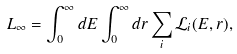<formula> <loc_0><loc_0><loc_500><loc_500>L _ { \infty } = \int _ { 0 } ^ { \infty } d E \int _ { 0 } ^ { \infty } d r \sum _ { i } \mathcal { L } _ { i } ( E , r ) ,</formula> 